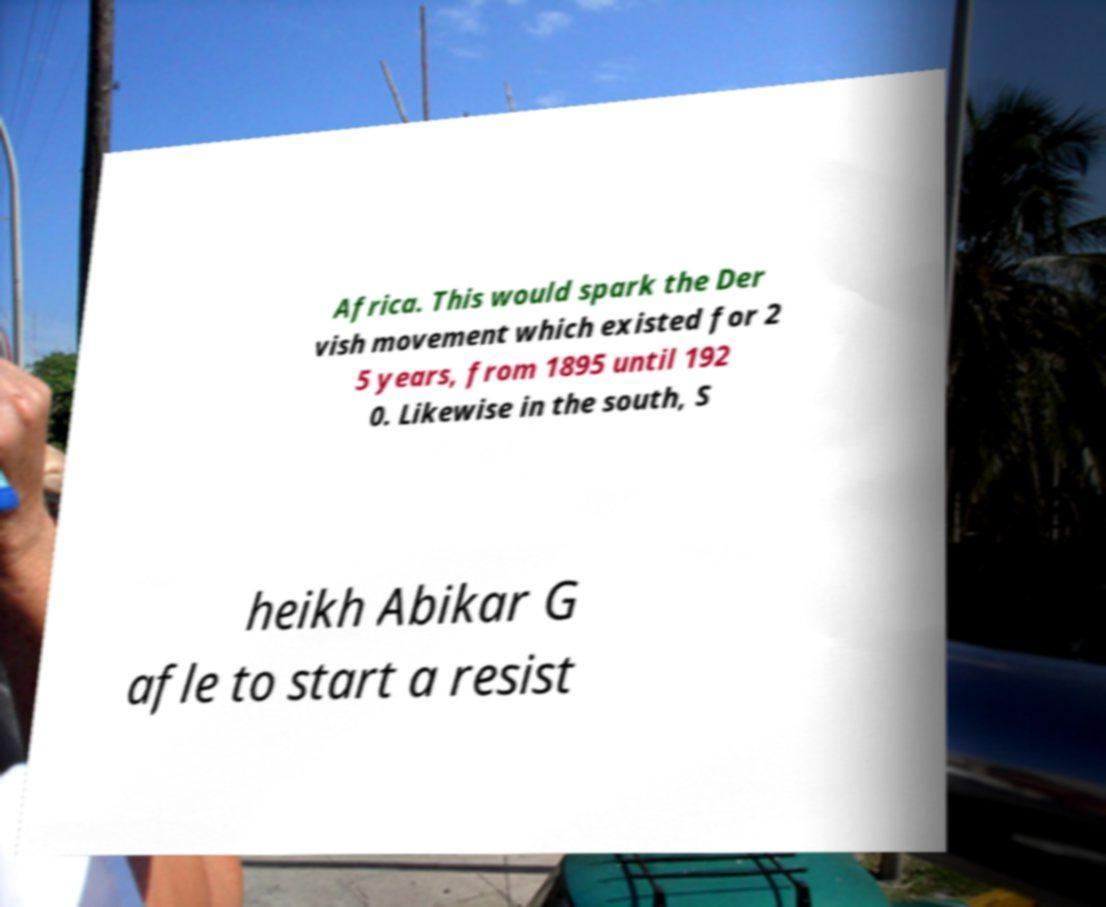What messages or text are displayed in this image? I need them in a readable, typed format. Africa. This would spark the Der vish movement which existed for 2 5 years, from 1895 until 192 0. Likewise in the south, S heikh Abikar G afle to start a resist 